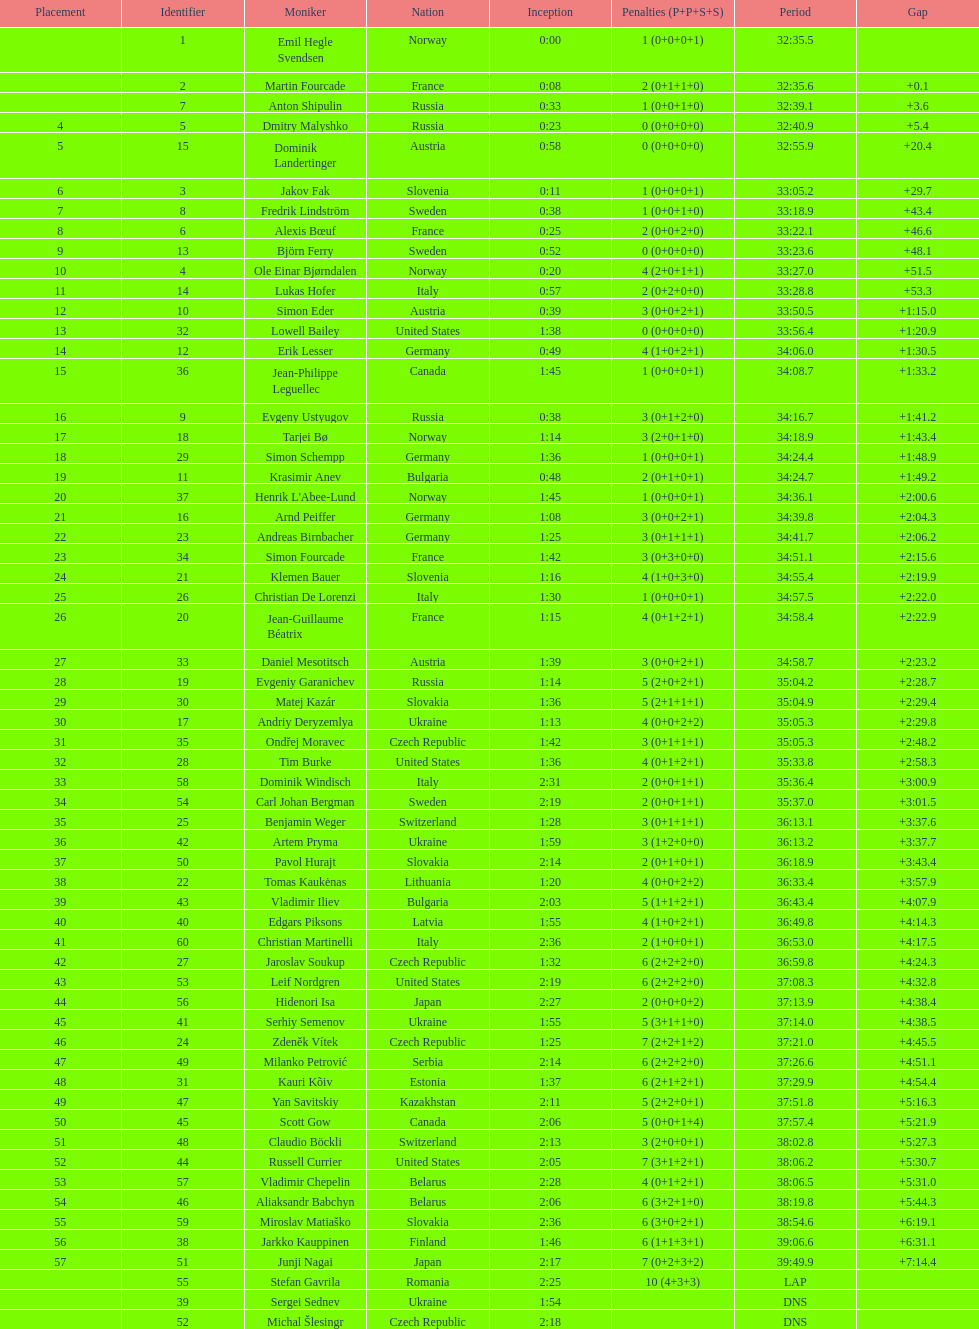Would you be able to parse every entry in this table? {'header': ['Placement', 'Identifier', 'Moniker', 'Nation', 'Inception', 'Penalties (P+P+S+S)', 'Period', 'Gap'], 'rows': [['', '1', 'Emil Hegle Svendsen', 'Norway', '0:00', '1 (0+0+0+1)', '32:35.5', ''], ['', '2', 'Martin Fourcade', 'France', '0:08', '2 (0+1+1+0)', '32:35.6', '+0.1'], ['', '7', 'Anton Shipulin', 'Russia', '0:33', '1 (0+0+1+0)', '32:39.1', '+3.6'], ['4', '5', 'Dmitry Malyshko', 'Russia', '0:23', '0 (0+0+0+0)', '32:40.9', '+5.4'], ['5', '15', 'Dominik Landertinger', 'Austria', '0:58', '0 (0+0+0+0)', '32:55.9', '+20.4'], ['6', '3', 'Jakov Fak', 'Slovenia', '0:11', '1 (0+0+0+1)', '33:05.2', '+29.7'], ['7', '8', 'Fredrik Lindström', 'Sweden', '0:38', '1 (0+0+1+0)', '33:18.9', '+43.4'], ['8', '6', 'Alexis Bœuf', 'France', '0:25', '2 (0+0+2+0)', '33:22.1', '+46.6'], ['9', '13', 'Björn Ferry', 'Sweden', '0:52', '0 (0+0+0+0)', '33:23.6', '+48.1'], ['10', '4', 'Ole Einar Bjørndalen', 'Norway', '0:20', '4 (2+0+1+1)', '33:27.0', '+51.5'], ['11', '14', 'Lukas Hofer', 'Italy', '0:57', '2 (0+2+0+0)', '33:28.8', '+53.3'], ['12', '10', 'Simon Eder', 'Austria', '0:39', '3 (0+0+2+1)', '33:50.5', '+1:15.0'], ['13', '32', 'Lowell Bailey', 'United States', '1:38', '0 (0+0+0+0)', '33:56.4', '+1:20.9'], ['14', '12', 'Erik Lesser', 'Germany', '0:49', '4 (1+0+2+1)', '34:06.0', '+1:30.5'], ['15', '36', 'Jean-Philippe Leguellec', 'Canada', '1:45', '1 (0+0+0+1)', '34:08.7', '+1:33.2'], ['16', '9', 'Evgeny Ustyugov', 'Russia', '0:38', '3 (0+1+2+0)', '34:16.7', '+1:41.2'], ['17', '18', 'Tarjei Bø', 'Norway', '1:14', '3 (2+0+1+0)', '34:18.9', '+1:43.4'], ['18', '29', 'Simon Schempp', 'Germany', '1:36', '1 (0+0+0+1)', '34:24.4', '+1:48.9'], ['19', '11', 'Krasimir Anev', 'Bulgaria', '0:48', '2 (0+1+0+1)', '34:24.7', '+1:49.2'], ['20', '37', "Henrik L'Abee-Lund", 'Norway', '1:45', '1 (0+0+0+1)', '34:36.1', '+2:00.6'], ['21', '16', 'Arnd Peiffer', 'Germany', '1:08', '3 (0+0+2+1)', '34:39.8', '+2:04.3'], ['22', '23', 'Andreas Birnbacher', 'Germany', '1:25', '3 (0+1+1+1)', '34:41.7', '+2:06.2'], ['23', '34', 'Simon Fourcade', 'France', '1:42', '3 (0+3+0+0)', '34:51.1', '+2:15.6'], ['24', '21', 'Klemen Bauer', 'Slovenia', '1:16', '4 (1+0+3+0)', '34:55.4', '+2:19.9'], ['25', '26', 'Christian De Lorenzi', 'Italy', '1:30', '1 (0+0+0+1)', '34:57.5', '+2:22.0'], ['26', '20', 'Jean-Guillaume Béatrix', 'France', '1:15', '4 (0+1+2+1)', '34:58.4', '+2:22.9'], ['27', '33', 'Daniel Mesotitsch', 'Austria', '1:39', '3 (0+0+2+1)', '34:58.7', '+2:23.2'], ['28', '19', 'Evgeniy Garanichev', 'Russia', '1:14', '5 (2+0+2+1)', '35:04.2', '+2:28.7'], ['29', '30', 'Matej Kazár', 'Slovakia', '1:36', '5 (2+1+1+1)', '35:04.9', '+2:29.4'], ['30', '17', 'Andriy Deryzemlya', 'Ukraine', '1:13', '4 (0+0+2+2)', '35:05.3', '+2:29.8'], ['31', '35', 'Ondřej Moravec', 'Czech Republic', '1:42', '3 (0+1+1+1)', '35:05.3', '+2:48.2'], ['32', '28', 'Tim Burke', 'United States', '1:36', '4 (0+1+2+1)', '35:33.8', '+2:58.3'], ['33', '58', 'Dominik Windisch', 'Italy', '2:31', '2 (0+0+1+1)', '35:36.4', '+3:00.9'], ['34', '54', 'Carl Johan Bergman', 'Sweden', '2:19', '2 (0+0+1+1)', '35:37.0', '+3:01.5'], ['35', '25', 'Benjamin Weger', 'Switzerland', '1:28', '3 (0+1+1+1)', '36:13.1', '+3:37.6'], ['36', '42', 'Artem Pryma', 'Ukraine', '1:59', '3 (1+2+0+0)', '36:13.2', '+3:37.7'], ['37', '50', 'Pavol Hurajt', 'Slovakia', '2:14', '2 (0+1+0+1)', '36:18.9', '+3:43.4'], ['38', '22', 'Tomas Kaukėnas', 'Lithuania', '1:20', '4 (0+0+2+2)', '36:33.4', '+3:57.9'], ['39', '43', 'Vladimir Iliev', 'Bulgaria', '2:03', '5 (1+1+2+1)', '36:43.4', '+4:07.9'], ['40', '40', 'Edgars Piksons', 'Latvia', '1:55', '4 (1+0+2+1)', '36:49.8', '+4:14.3'], ['41', '60', 'Christian Martinelli', 'Italy', '2:36', '2 (1+0+0+1)', '36:53.0', '+4:17.5'], ['42', '27', 'Jaroslav Soukup', 'Czech Republic', '1:32', '6 (2+2+2+0)', '36:59.8', '+4:24.3'], ['43', '53', 'Leif Nordgren', 'United States', '2:19', '6 (2+2+2+0)', '37:08.3', '+4:32.8'], ['44', '56', 'Hidenori Isa', 'Japan', '2:27', '2 (0+0+0+2)', '37:13.9', '+4:38.4'], ['45', '41', 'Serhiy Semenov', 'Ukraine', '1:55', '5 (3+1+1+0)', '37:14.0', '+4:38.5'], ['46', '24', 'Zdeněk Vítek', 'Czech Republic', '1:25', '7 (2+2+1+2)', '37:21.0', '+4:45.5'], ['47', '49', 'Milanko Petrović', 'Serbia', '2:14', '6 (2+2+2+0)', '37:26.6', '+4:51.1'], ['48', '31', 'Kauri Kõiv', 'Estonia', '1:37', '6 (2+1+2+1)', '37:29.9', '+4:54.4'], ['49', '47', 'Yan Savitskiy', 'Kazakhstan', '2:11', '5 (2+2+0+1)', '37:51.8', '+5:16.3'], ['50', '45', 'Scott Gow', 'Canada', '2:06', '5 (0+0+1+4)', '37:57.4', '+5:21.9'], ['51', '48', 'Claudio Böckli', 'Switzerland', '2:13', '3 (2+0+0+1)', '38:02.8', '+5:27.3'], ['52', '44', 'Russell Currier', 'United States', '2:05', '7 (3+1+2+1)', '38:06.2', '+5:30.7'], ['53', '57', 'Vladimir Chepelin', 'Belarus', '2:28', '4 (0+1+2+1)', '38:06.5', '+5:31.0'], ['54', '46', 'Aliaksandr Babchyn', 'Belarus', '2:06', '6 (3+2+1+0)', '38:19.8', '+5:44.3'], ['55', '59', 'Miroslav Matiaško', 'Slovakia', '2:36', '6 (3+0+2+1)', '38:54.6', '+6:19.1'], ['56', '38', 'Jarkko Kauppinen', 'Finland', '1:46', '6 (1+1+3+1)', '39:06.6', '+6:31.1'], ['57', '51', 'Junji Nagai', 'Japan', '2:17', '7 (0+2+3+2)', '39:49.9', '+7:14.4'], ['', '55', 'Stefan Gavrila', 'Romania', '2:25', '10 (4+3+3)', 'LAP', ''], ['', '39', 'Sergei Sednev', 'Ukraine', '1:54', '', 'DNS', ''], ['', '52', 'Michal Šlesingr', 'Czech Republic', '2:18', '', 'DNS', '']]} How many penalties did germany get all together? 11. 